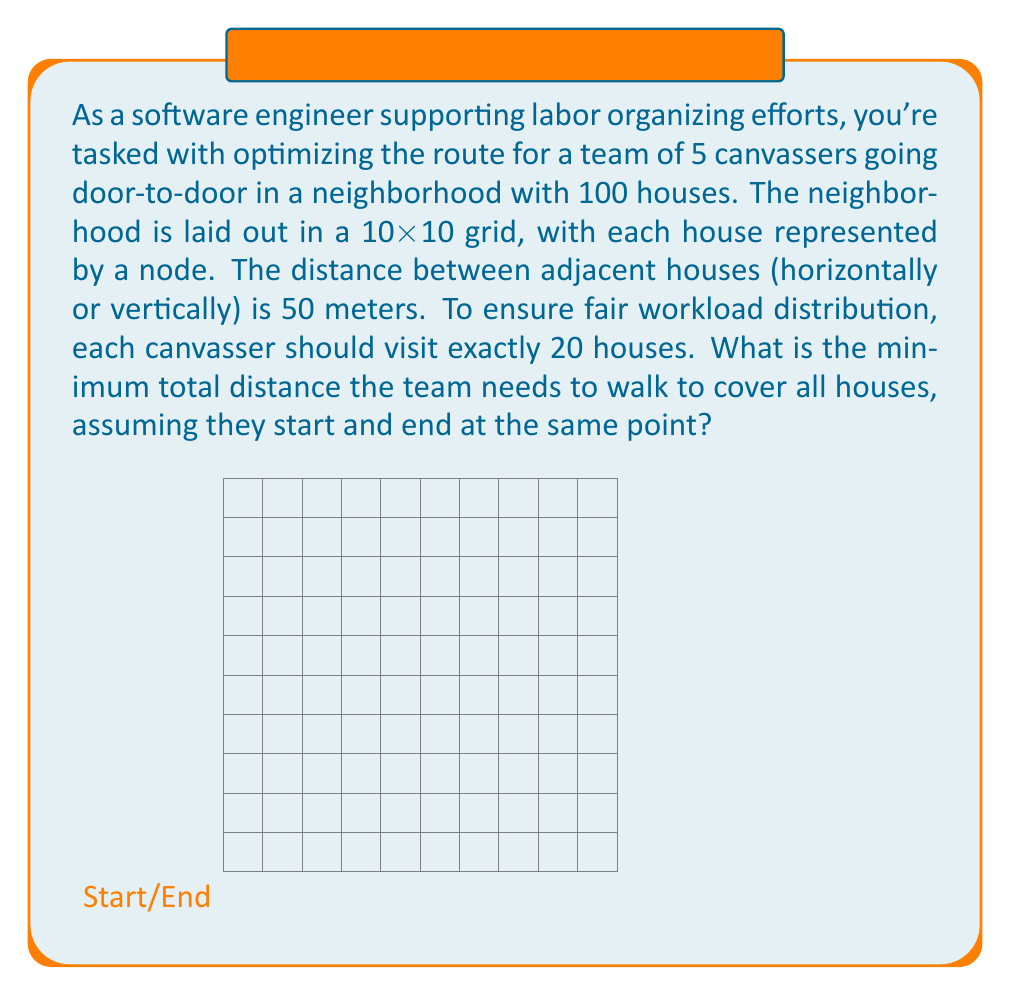Show me your answer to this math problem. To solve this problem, we need to apply the principles of the Traveling Salesman Problem (TSP) with multiple agents, also known as the Vehicle Routing Problem (VRP). Here's a step-by-step approach:

1) First, we need to calculate the total number of edges in the grid:
   Horizontal edges: 10 * 11 = 110
   Vertical edges: 10 * 11 = 110
   Total edges: 110 + 110 = 220

2) To visit all houses, we need to traverse at least 99 edges (to connect 100 nodes).

3) For a fair distribution, each canvasser visits 20 houses. This means each canvasser's path should contain 19 edges between houses.

4) The total number of edges traversed by all canvassers between houses:
   19 edges * 5 canvassers = 95 edges

5) We need 4 additional edges to connect the start/end point to the first and last house for each canvasser:
   95 + 4 = 99 edges

This is the minimum number of edges required to visit all houses, which matches our expectation from step 2.

6) Calculate the total distance:
   99 edges * 50 meters/edge = 4950 meters

Therefore, the minimum total distance the team needs to walk is 4950 meters.

Note: This solution assumes an optimal path exists that allows for equal distribution of houses and minimal backtracking. In practice, finding this exact path is an NP-hard problem, and heuristic algorithms would be used for larger datasets.
Answer: The minimum total distance the team needs to walk to cover all houses is 4950 meters. 